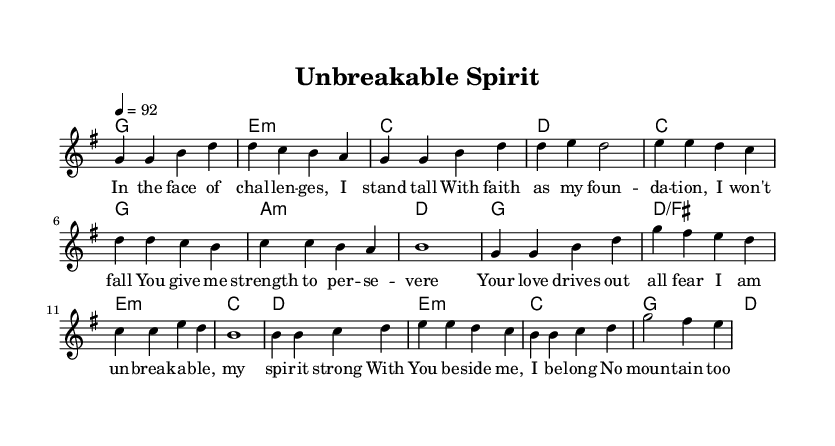What is the key signature of this music? The key signature is G major, which contains one sharp (F#).
Answer: G major What is the time signature of the piece? The time signature is 4/4, indicating four beats per measure.
Answer: 4/4 What is the tempo marking for this piece? The tempo marking indicates a speed of 92 beats per minute, which sets the pace for the performance.
Answer: 92 What is the first chord played in the verse? The first chord in the verse is G major, as indicated by the chord notation at the start of the verse section.
Answer: G How many lines are there in the chorus lyrics? The chorus lyrics consist of four lines, as evidenced by the structure of the lyrical content under the chorus melody.
Answer: Four In the bridge, what is the last lyric line? The last lyric line in the bridge is "With Your strength, I'm ready to go." This is derived from the lyrics indicated below the melody for the bridge section.
Answer: With Your strength, I'm ready to go Which thematic aspect is emphasized in the song? The song emphasizes themes of mental strength and resilience, evident from the lyrics that focus on overcoming challenges and reliance on faith.
Answer: Mental strength and resilience 